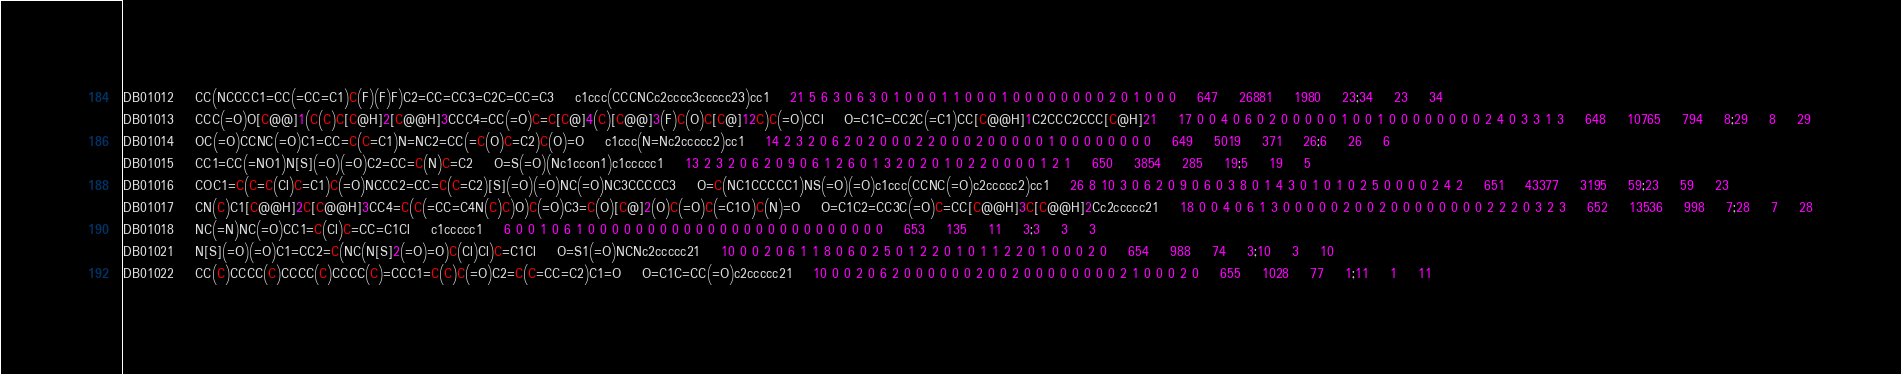Convert code to text. <code><loc_0><loc_0><loc_500><loc_500><_SQL_>DB01012	CC(NCCCC1=CC(=CC=C1)C(F)(F)F)C2=CC=CC3=C2C=CC=C3	c1ccc(CCCNCc2cccc3ccccc23)cc1	21 5 6 3 0 6 3 0 1 0 0 0 1 1 0 0 0 1 0 0 0 0 0 0 0 0 2 0 1 0 0 0	647	26881	1980	23;34	23	34
DB01013	CCC(=O)O[C@@]1(C(C)C[C@H]2[C@@H]3CCC4=CC(=O)C=C[C@]4(C)[C@@]3(F)C(O)C[C@]12C)C(=O)CCl	O=C1C=CC2C(=C1)CC[C@@H]1C2CCC2CCC[C@H]21	17 0 0 4 0 6 0 2 0 0 0 0 0 1 0 0 1 0 0 0 0 0 0 0 0 2 4 0 3 3 1 3	648	10765	794	8;29	8	29
DB01014	OC(=O)CCNC(=O)C1=CC=C(C=C1)N=NC2=CC(=C(O)C=C2)C(O)=O	c1ccc(N=Nc2ccccc2)cc1	14 2 3 2 0 6 2 0 2 0 0 0 2 2 0 0 0 2 0 0 0 0 0 1 0 0 0 0 0 0 0 0	649	5019	371	26;6	26	6
DB01015	CC1=CC(=NO1)N[S](=O)(=O)C2=CC=C(N)C=C2	O=S(=O)(Nc1ccon1)c1ccccc1	13 2 3 2 0 6 2 0 9 0 6 1 2 6 0 1 3 2 0 2 0 1 0 2 2 0 0 0 0 1 2 1	650	3854	285	19;5	19	5
DB01016	COC1=C(C=C(Cl)C=C1)C(=O)NCCC2=CC=C(C=C2)[S](=O)(=O)NC(=O)NC3CCCCC3	O=C(NC1CCCCC1)NS(=O)(=O)c1ccc(CCNC(=O)c2ccccc2)cc1	26 8 10 3 0 6 2 0 9 0 6 0 3 8 0 1 4 3 0 1 0 1 0 2 5 0 0 0 0 2 4 2	651	43377	3195	59;23	59	23
DB01017	CN(C)C1[C@@H]2C[C@@H]3CC4=C(C(=CC=C4N(C)C)O)C(=O)C3=C(O)[C@]2(O)C(=O)C(=C1O)C(N)=O	O=C1C2=CC3C(=O)C=CC[C@@H]3C[C@@H]2Cc2ccccc21	18 0 0 4 0 6 1 3 0 0 0 0 0 2 0 0 2 0 0 0 0 0 0 0 0 2 2 2 0 3 2 3	652	13536	998	7;28	7	28
DB01018	NC(=N)NC(=O)CC1=C(Cl)C=CC=C1Cl	c1ccccc1	6 0 0 1 0 6 1 0 0 0 0 0 0 0 0 0 0 0 0 0 0 0 0 0 0 0 0 0 0 0 0 0	653	135	11	3;3	3	3
DB01021	N[S](=O)(=O)C1=CC2=C(NC(N[S]2(=O)=O)C(Cl)Cl)C=C1Cl	O=S1(=O)NCNc2ccccc21	10 0 0 2 0 6 1 1 8 0 6 0 2 5 0 1 2 2 0 1 0 1 1 2 2 0 1 0 0 0 2 0	654	988	74	3;10	3	10
DB01022	CC(C)CCCC(C)CCCC(C)CCCC(C)=CCC1=C(C)C(=O)C2=C(C=CC=C2)C1=O	O=C1C=CC(=O)c2ccccc21	10 0 0 2 0 6 2 0 0 0 0 0 0 2 0 0 2 0 0 0 0 0 0 0 0 2 1 0 0 0 2 0	655	1028	77	1;11	1	11</code> 